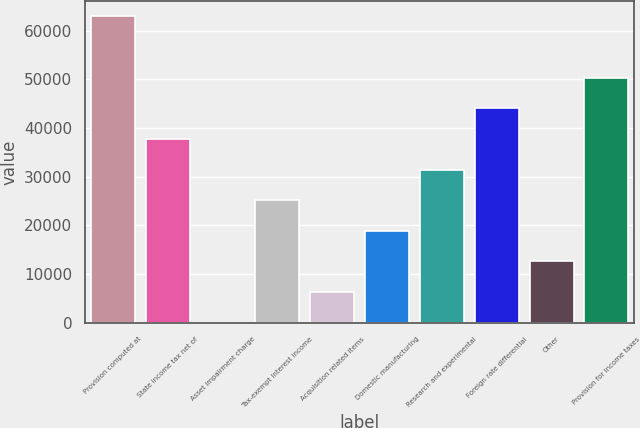Convert chart. <chart><loc_0><loc_0><loc_500><loc_500><bar_chart><fcel>Provision computed at<fcel>State income tax net of<fcel>Asset impairment charge<fcel>Tax-exempt interest income<fcel>Acquisition related items<fcel>Domestic manufacturing<fcel>Research and experimental<fcel>Foreign rate differential<fcel>Other<fcel>Provision for income taxes<nl><fcel>62905<fcel>37743.2<fcel>0.42<fcel>25162.3<fcel>6290.88<fcel>18871.8<fcel>31452.7<fcel>44033.6<fcel>12581.3<fcel>50324.1<nl></chart> 